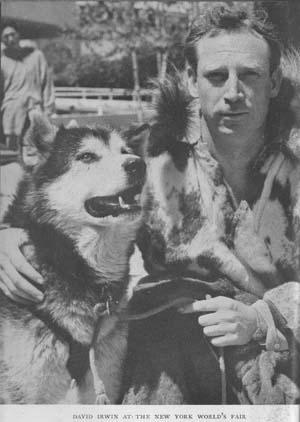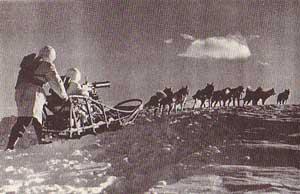The first image is the image on the left, the second image is the image on the right. Assess this claim about the two images: "An image shows a forward-facing person wearing fur, posing next to at least one forward-facing sled dog.". Correct or not? Answer yes or no. Yes. The first image is the image on the left, the second image is the image on the right. Given the left and right images, does the statement "In at least one image there is a single person facing forward holding their huskey in the snow." hold true? Answer yes or no. Yes. 